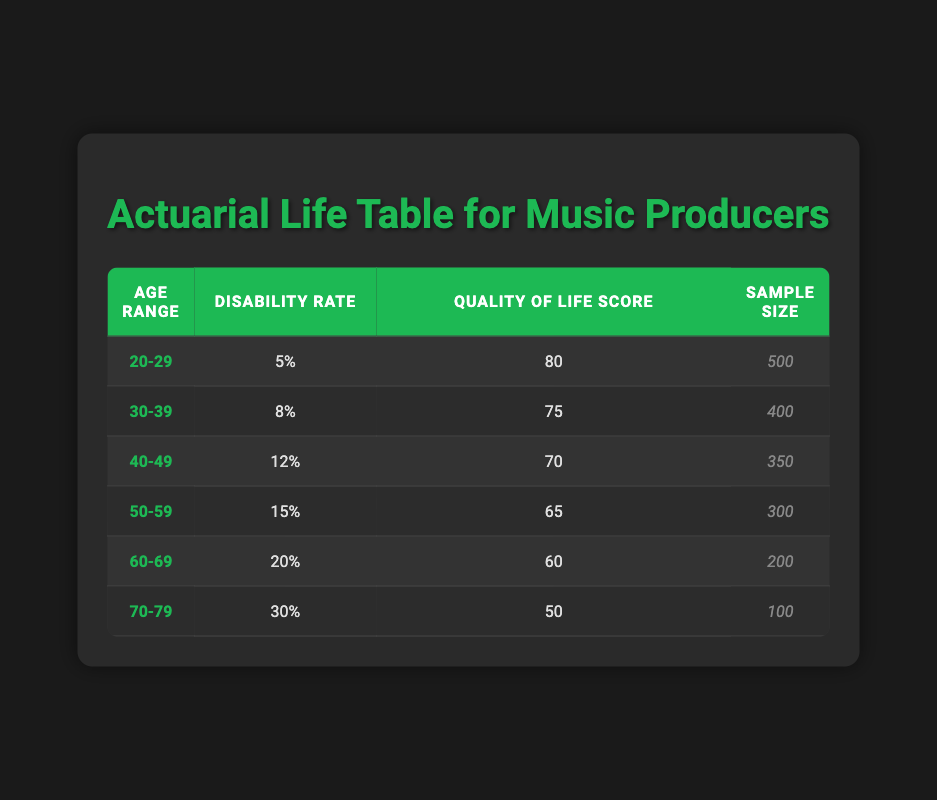What is the disability rate for the age group 40-49? The specific row for the age group 40-49 provides a disability rate of 0.12 or 12%.
Answer: 12% Which age group has the highest quality of life score? By comparing the quality of life scores across all age groups, the age group 20-29 has the highest score of 80.
Answer: 20-29 What is the average disability rate for all age groups? To find the average, sum the disability rates: (0.05 + 0.08 + 0.12 + 0.15 + 0.20 + 0.30) = 0.90, and then divide by the number of groups (6): 0.90 / 6 = 0.15 or 15%.
Answer: 15% Is the quality of life score for the age group 50-59 equal to or greater than that of the age group 60-69? The quality of life score for 50-59 is 65, and for 60-69 it is 60. Since 65 is greater than 60, the statement is true.
Answer: Yes What is the difference in disability rates between the age groups 30-39 and 50-59? The disability rate for 30-39 is 0.08 (or 8%) and for 50-59 is 0.15 (or 15%). The difference is 0.15 - 0.08 = 0.07, so the difference is 7%.
Answer: 7% How many participants are there in total across all age groups? The total sample size is found by adding the sizes from each group: 500 + 400 + 350 + 300 + 200 + 100 = 1850.
Answer: 1850 Does the disability rate increase with age? By observing the table, the disability rates clearly increase from 0.05 in the youngest group to 0.30 in the oldest group. This indicates an upward trend.
Answer: Yes What is the average quality of life score for age groups 30-39 and 40-49? First, sum the quality of life scores for these two groups: 75 (30-39) + 70 (40-49) = 145. Then divide by the number of groups (2): 145 / 2 = 72.5.
Answer: 72.5 